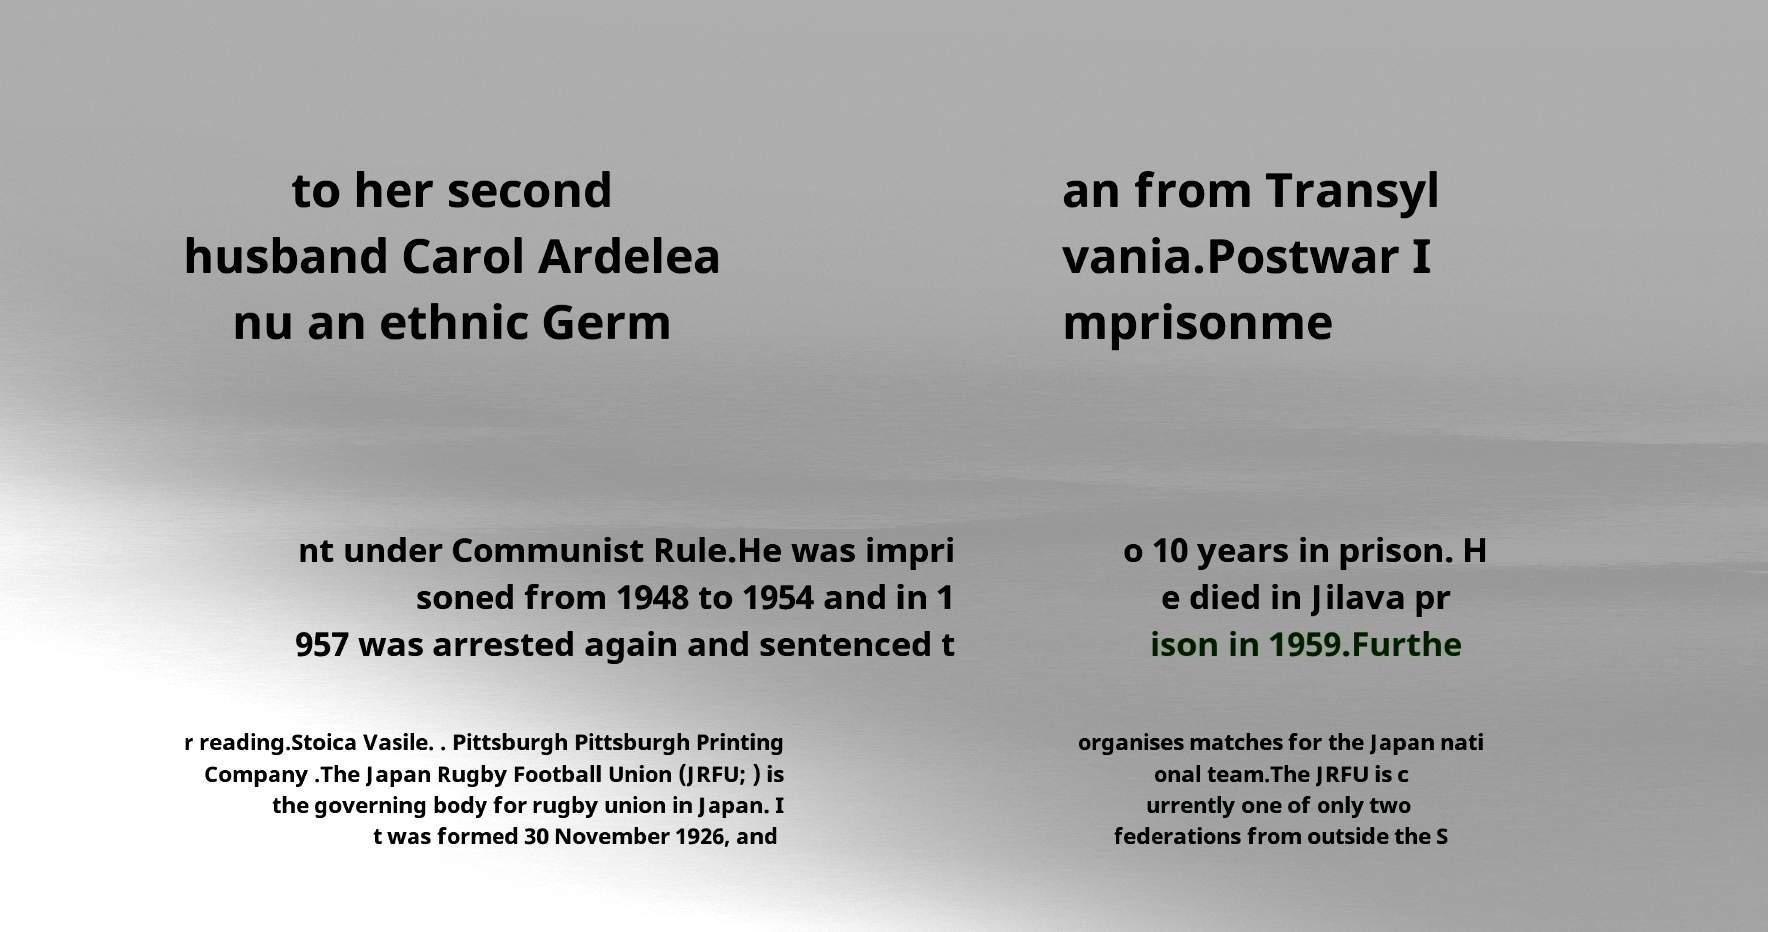For documentation purposes, I need the text within this image transcribed. Could you provide that? to her second husband Carol Ardelea nu an ethnic Germ an from Transyl vania.Postwar I mprisonme nt under Communist Rule.He was impri soned from 1948 to 1954 and in 1 957 was arrested again and sentenced t o 10 years in prison. H e died in Jilava pr ison in 1959.Furthe r reading.Stoica Vasile. . Pittsburgh Pittsburgh Printing Company .The Japan Rugby Football Union (JRFU; ) is the governing body for rugby union in Japan. I t was formed 30 November 1926, and organises matches for the Japan nati onal team.The JRFU is c urrently one of only two federations from outside the S 